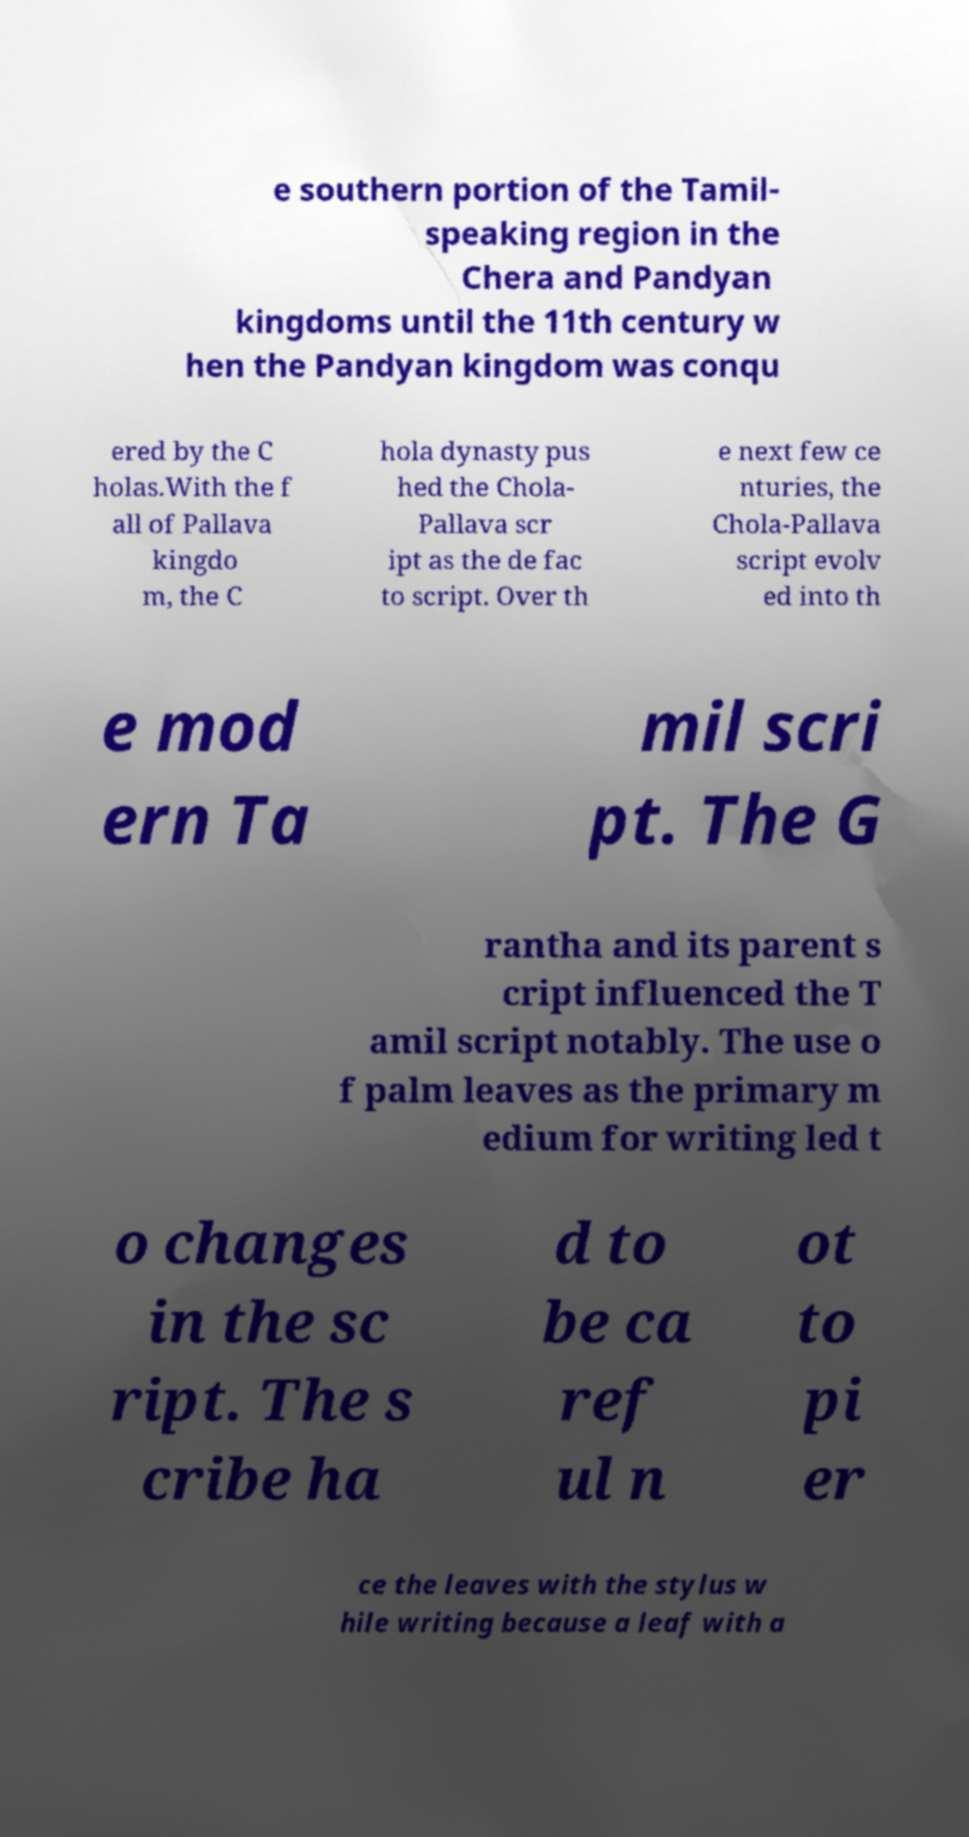Could you extract and type out the text from this image? e southern portion of the Tamil- speaking region in the Chera and Pandyan kingdoms until the 11th century w hen the Pandyan kingdom was conqu ered by the C holas.With the f all of Pallava kingdo m, the C hola dynasty pus hed the Chola- Pallava scr ipt as the de fac to script. Over th e next few ce nturies, the Chola-Pallava script evolv ed into th e mod ern Ta mil scri pt. The G rantha and its parent s cript influenced the T amil script notably. The use o f palm leaves as the primary m edium for writing led t o changes in the sc ript. The s cribe ha d to be ca ref ul n ot to pi er ce the leaves with the stylus w hile writing because a leaf with a 